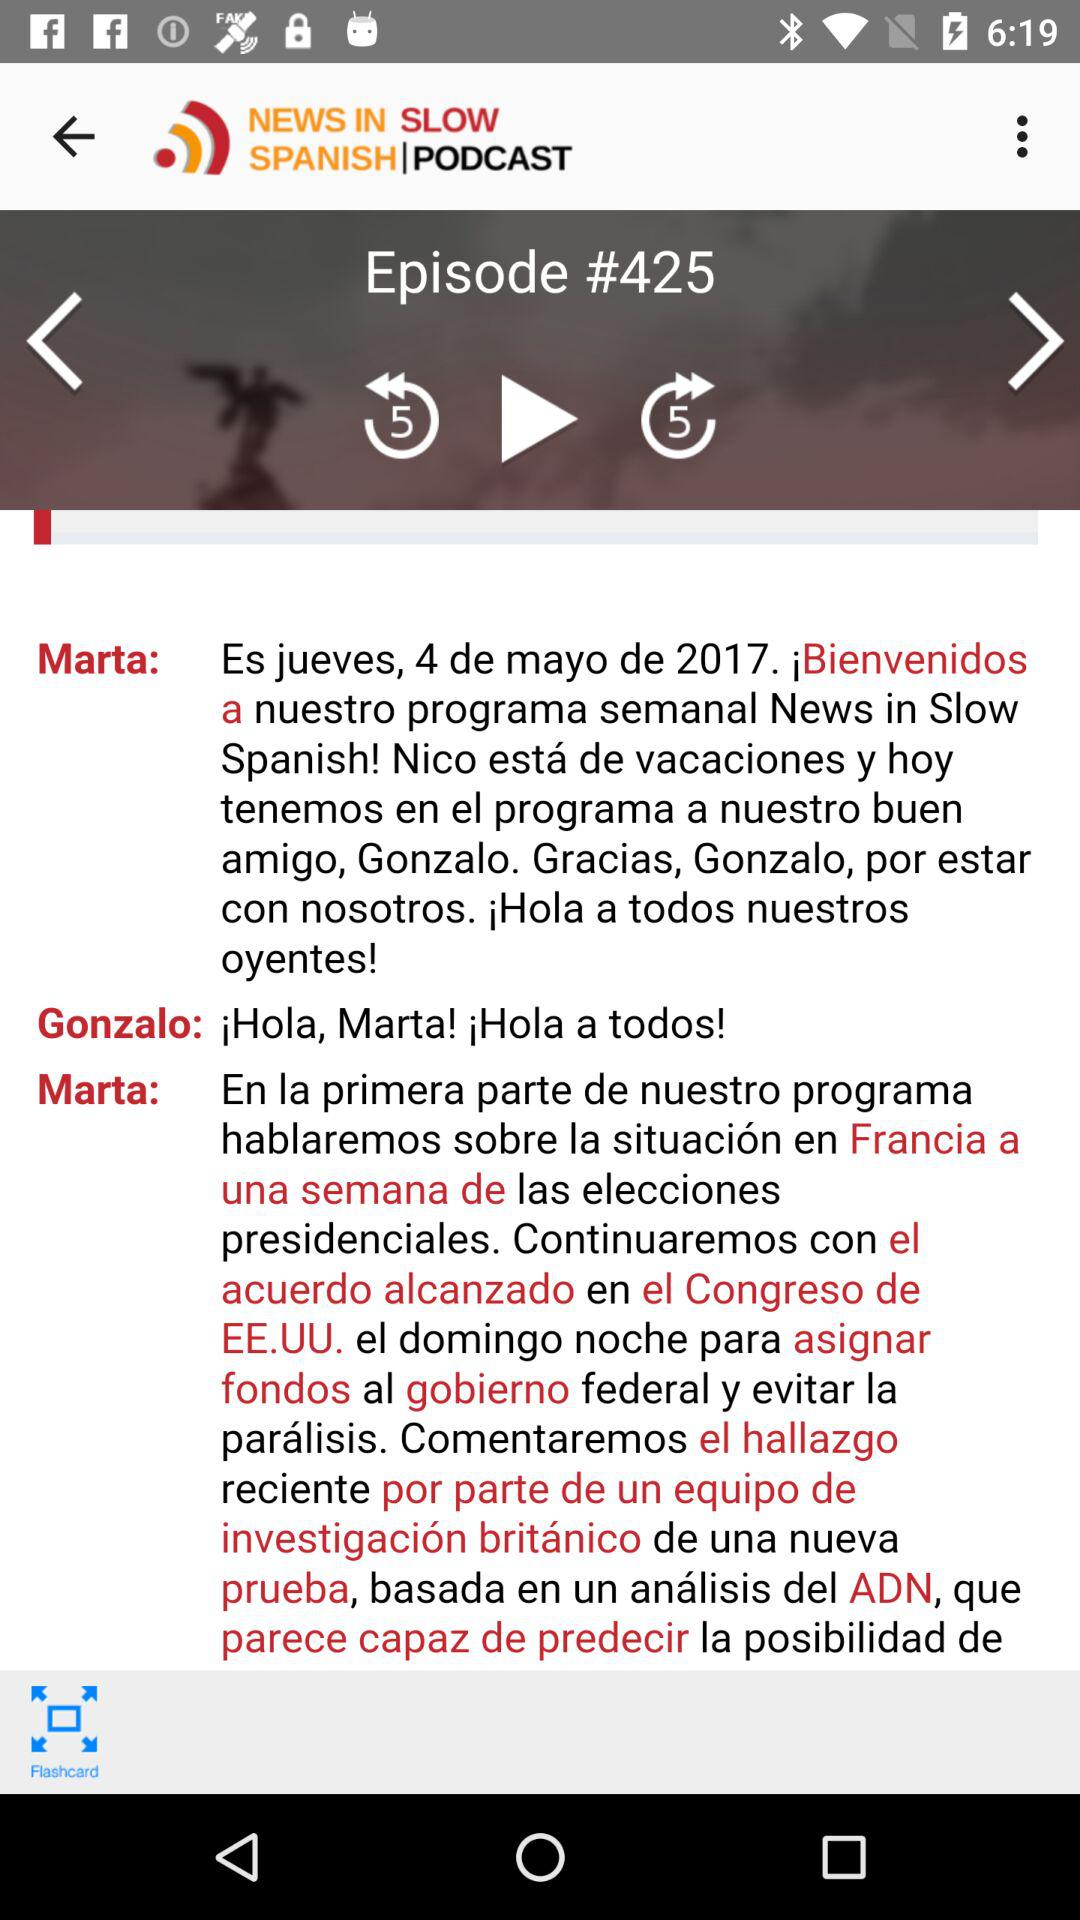How many people are in the podcast?
Answer the question using a single word or phrase. 2 